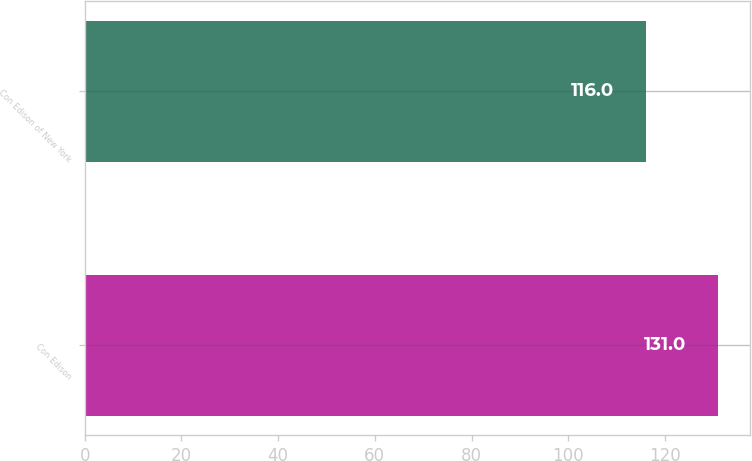<chart> <loc_0><loc_0><loc_500><loc_500><bar_chart><fcel>Con Edison<fcel>Con Edison of New York<nl><fcel>131<fcel>116<nl></chart> 